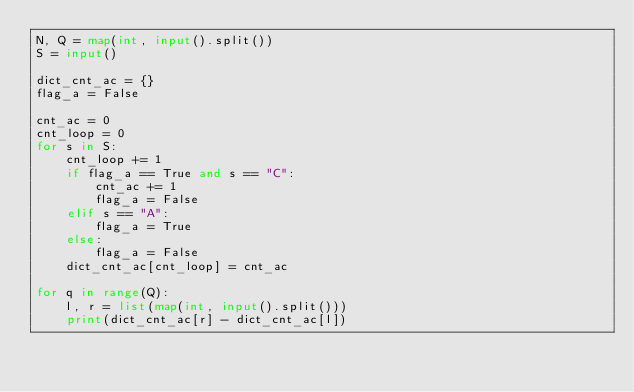Convert code to text. <code><loc_0><loc_0><loc_500><loc_500><_Python_>N, Q = map(int, input().split())
S = input()

dict_cnt_ac = {}
flag_a = False

cnt_ac = 0
cnt_loop = 0
for s in S:
    cnt_loop += 1
    if flag_a == True and s == "C":
        cnt_ac += 1
        flag_a = False
    elif s == "A":
        flag_a = True
    else:
        flag_a = False
    dict_cnt_ac[cnt_loop] = cnt_ac
    
for q in range(Q):
    l, r = list(map(int, input().split()))
    print(dict_cnt_ac[r] - dict_cnt_ac[l])
</code> 